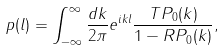<formula> <loc_0><loc_0><loc_500><loc_500>p ( l ) = \int _ { - \infty } ^ { \infty } \frac { d k } { 2 \pi } e ^ { i k l } \frac { T P _ { 0 } ( k ) } { 1 - R P _ { 0 } ( k ) } ,</formula> 